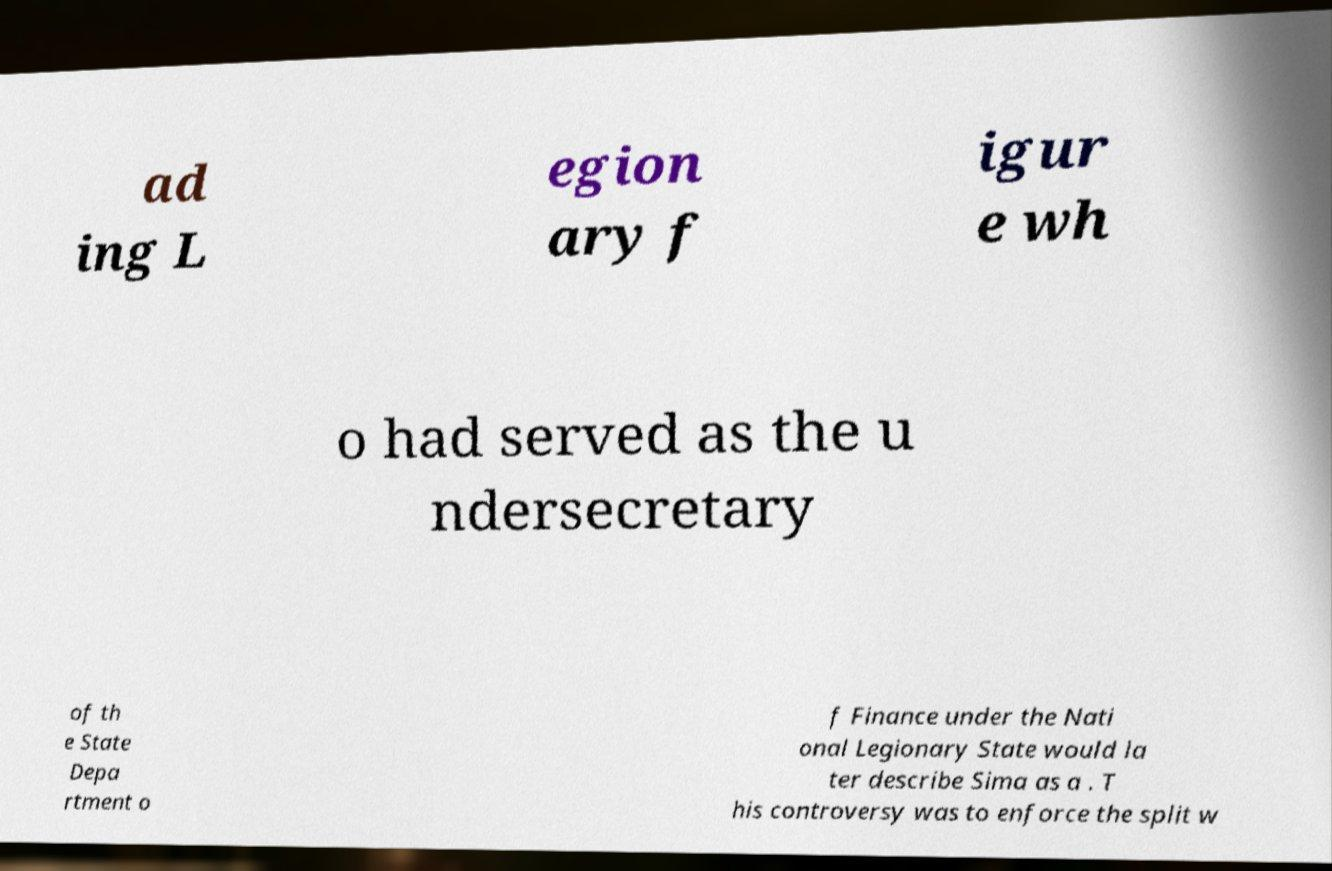Please identify and transcribe the text found in this image. ad ing L egion ary f igur e wh o had served as the u ndersecretary of th e State Depa rtment o f Finance under the Nati onal Legionary State would la ter describe Sima as a . T his controversy was to enforce the split w 